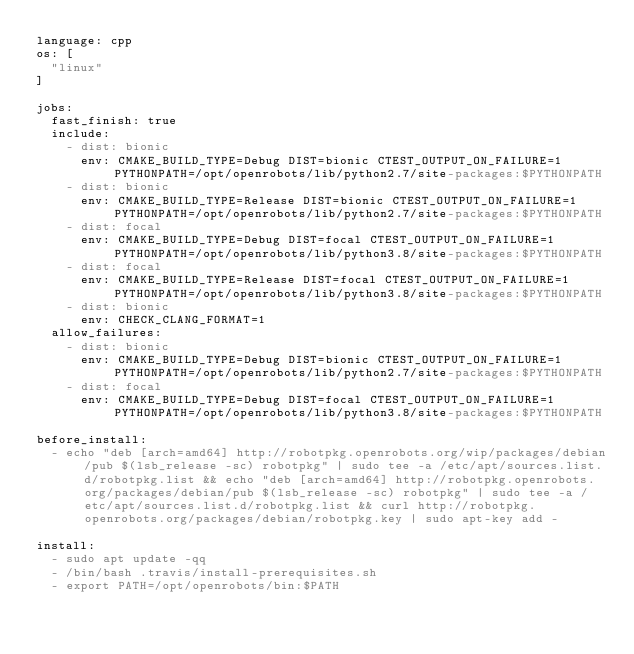<code> <loc_0><loc_0><loc_500><loc_500><_YAML_>language: cpp
os: [
  "linux"
]

jobs:
  fast_finish: true
  include:
    - dist: bionic
      env: CMAKE_BUILD_TYPE=Debug DIST=bionic CTEST_OUTPUT_ON_FAILURE=1 PYTHONPATH=/opt/openrobots/lib/python2.7/site-packages:$PYTHONPATH
    - dist: bionic
      env: CMAKE_BUILD_TYPE=Release DIST=bionic CTEST_OUTPUT_ON_FAILURE=1 PYTHONPATH=/opt/openrobots/lib/python2.7/site-packages:$PYTHONPATH
    - dist: focal
      env: CMAKE_BUILD_TYPE=Debug DIST=focal CTEST_OUTPUT_ON_FAILURE=1 PYTHONPATH=/opt/openrobots/lib/python3.8/site-packages:$PYTHONPATH
    - dist: focal
      env: CMAKE_BUILD_TYPE=Release DIST=focal CTEST_OUTPUT_ON_FAILURE=1 PYTHONPATH=/opt/openrobots/lib/python3.8/site-packages:$PYTHONPATH
    - dist: bionic
      env: CHECK_CLANG_FORMAT=1
  allow_failures:
    - dist: bionic
      env: CMAKE_BUILD_TYPE=Debug DIST=bionic CTEST_OUTPUT_ON_FAILURE=1 PYTHONPATH=/opt/openrobots/lib/python2.7/site-packages:$PYTHONPATH
    - dist: focal
      env: CMAKE_BUILD_TYPE=Debug DIST=focal CTEST_OUTPUT_ON_FAILURE=1 PYTHONPATH=/opt/openrobots/lib/python3.8/site-packages:$PYTHONPATH

before_install:
  - echo "deb [arch=amd64] http://robotpkg.openrobots.org/wip/packages/debian/pub $(lsb_release -sc) robotpkg" | sudo tee -a /etc/apt/sources.list.d/robotpkg.list && echo "deb [arch=amd64] http://robotpkg.openrobots.org/packages/debian/pub $(lsb_release -sc) robotpkg" | sudo tee -a /etc/apt/sources.list.d/robotpkg.list && curl http://robotpkg.openrobots.org/packages/debian/robotpkg.key | sudo apt-key add -

install:
  - sudo apt update -qq
  - /bin/bash .travis/install-prerequisites.sh
  - export PATH=/opt/openrobots/bin:$PATH</code> 